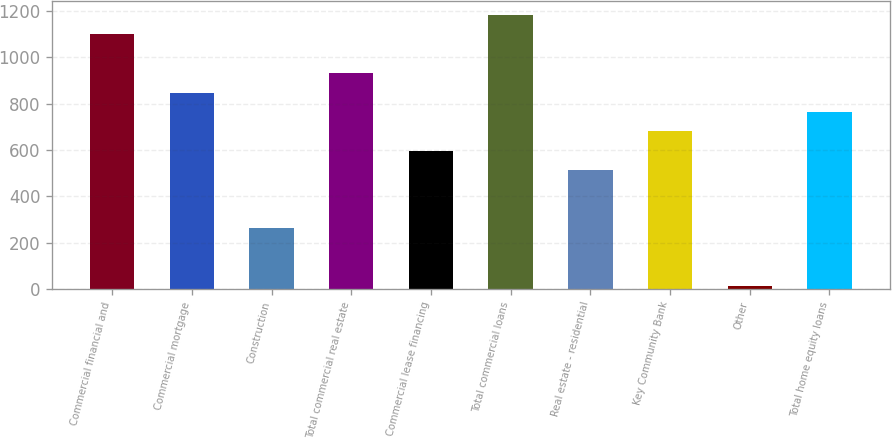Convert chart to OTSL. <chart><loc_0><loc_0><loc_500><loc_500><bar_chart><fcel>Commercial financial and<fcel>Commercial mortgage<fcel>Construction<fcel>Total commercial real estate<fcel>Commercial lease financing<fcel>Total commercial loans<fcel>Real estate - residential<fcel>Key Community Bank<fcel>Other<fcel>Total home equity loans<nl><fcel>1099.1<fcel>848<fcel>262.1<fcel>931.7<fcel>596.9<fcel>1182.8<fcel>513.2<fcel>680.6<fcel>11<fcel>764.3<nl></chart> 